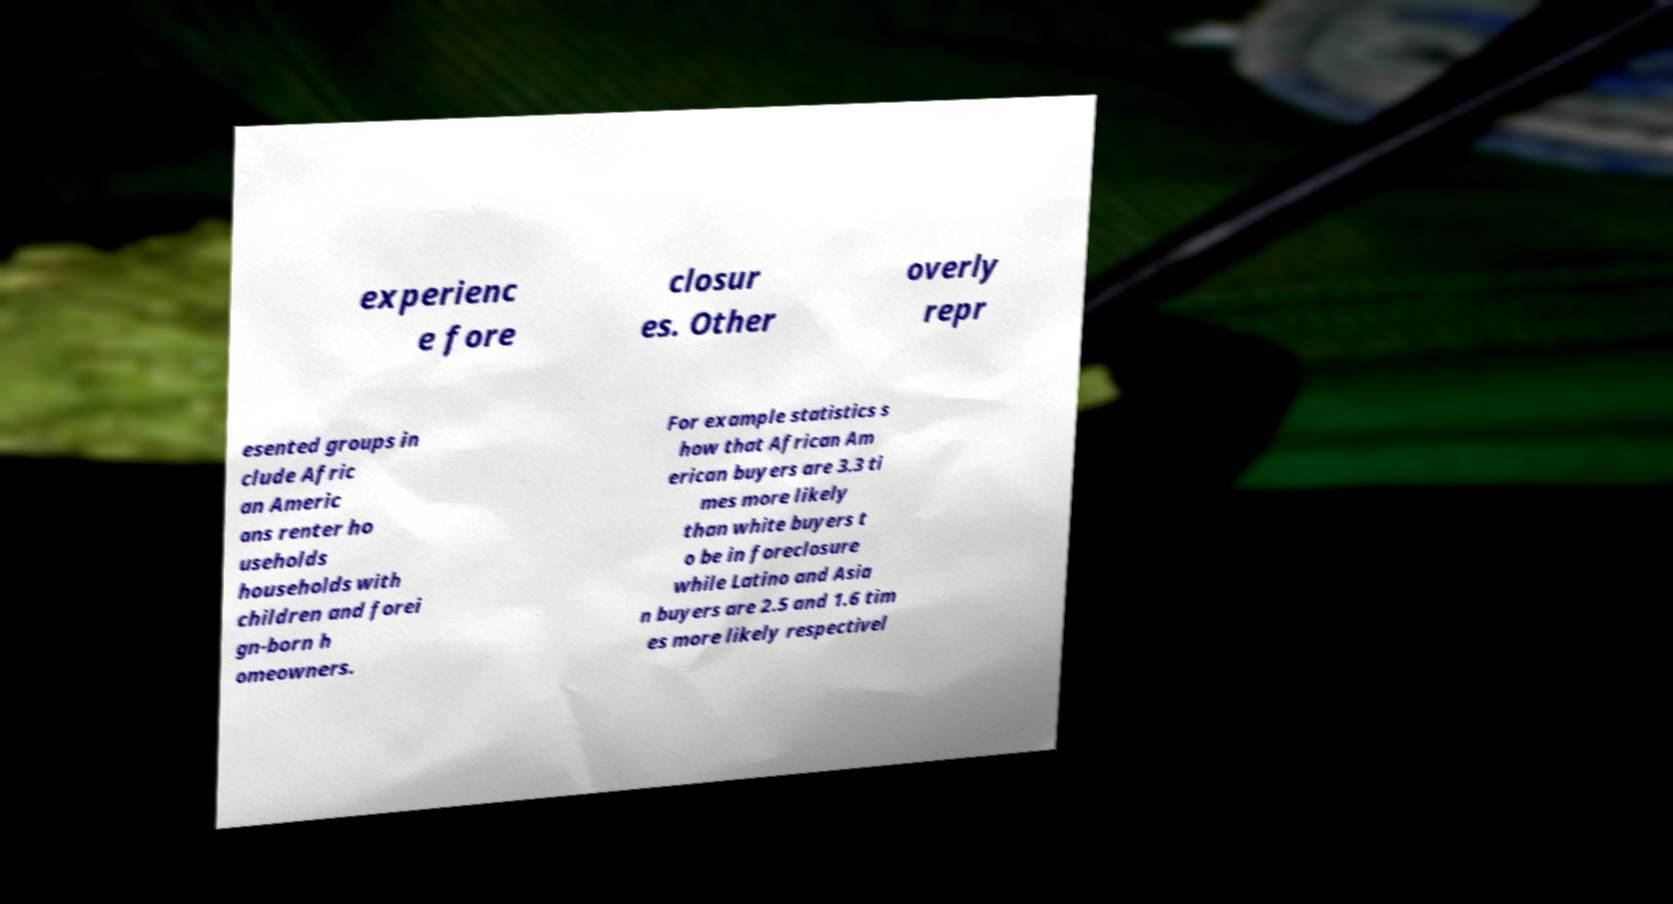What messages or text are displayed in this image? I need them in a readable, typed format. experienc e fore closur es. Other overly repr esented groups in clude Afric an Americ ans renter ho useholds households with children and forei gn-born h omeowners. For example statistics s how that African Am erican buyers are 3.3 ti mes more likely than white buyers t o be in foreclosure while Latino and Asia n buyers are 2.5 and 1.6 tim es more likely respectivel 